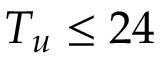Convert formula to latex. <formula><loc_0><loc_0><loc_500><loc_500>T _ { u } \leq 2 4</formula> 